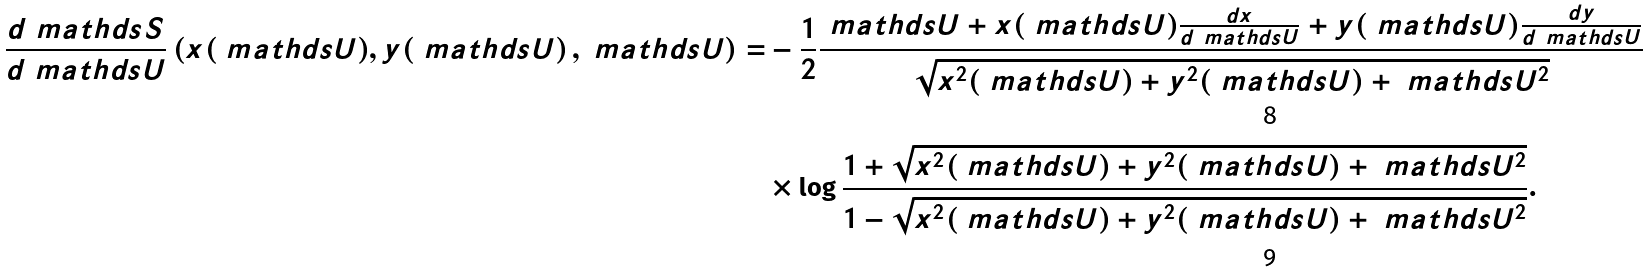Convert formula to latex. <formula><loc_0><loc_0><loc_500><loc_500>\frac { d \ m a t h d s { S } } { d \ m a t h d s { U } } \left ( x ( \ m a t h d s { U } ) , y ( \ m a t h d s { U } \right ) , \ m a t h d s { U } ) = & - \frac { 1 } { 2 } \frac { \ m a t h d s { U } + x ( \ m a t h d s { U } ) \frac { d x } { d \ m a t h d s { U } } + y ( \ m a t h d s { U } ) \frac { d y } { d \ m a t h d s { U } } } { \sqrt { x ^ { 2 } ( \ m a t h d s { U } ) + y ^ { 2 } ( \ m a t h d s { U } ) + \ m a t h d s { U } ^ { 2 } } } \\ & \times \log \frac { 1 + \sqrt { x ^ { 2 } ( \ m a t h d s { U } ) + y ^ { 2 } ( \ m a t h d s { U } ) + \ m a t h d s { U } ^ { 2 } } } { 1 - \sqrt { x ^ { 2 } ( \ m a t h d s { U } ) + y ^ { 2 } ( \ m a t h d s { U } ) + \ m a t h d s { U } ^ { 2 } } } .</formula> 